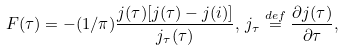<formula> <loc_0><loc_0><loc_500><loc_500>F ( \tau ) = - ( 1 / \pi ) \frac { j ( \tau ) [ j ( \tau ) - j ( i ) ] } { j _ { \tau } ( \tau ) } , \, j _ { \tau } \stackrel { d e f } { = } \frac { \partial j ( \tau ) } { \partial \tau } ,</formula> 